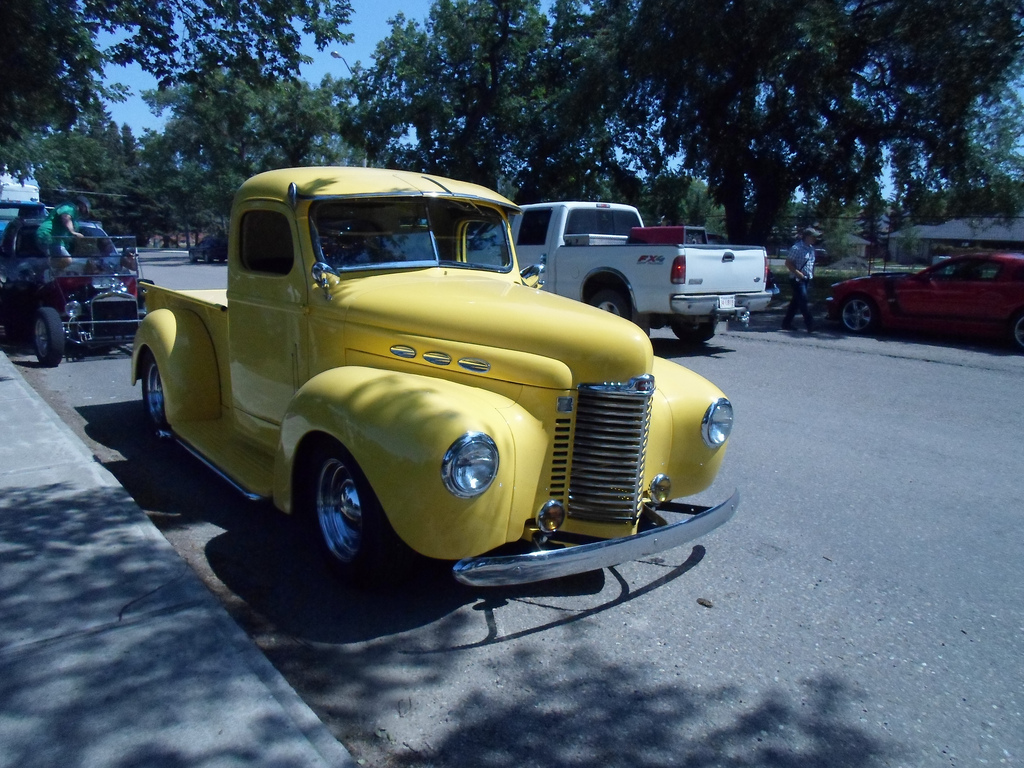Who is wearing the cap? In this scene, the man is the one wearing a cap, and he seems engaged in examining or admiring the vintage cars displayed around him. 